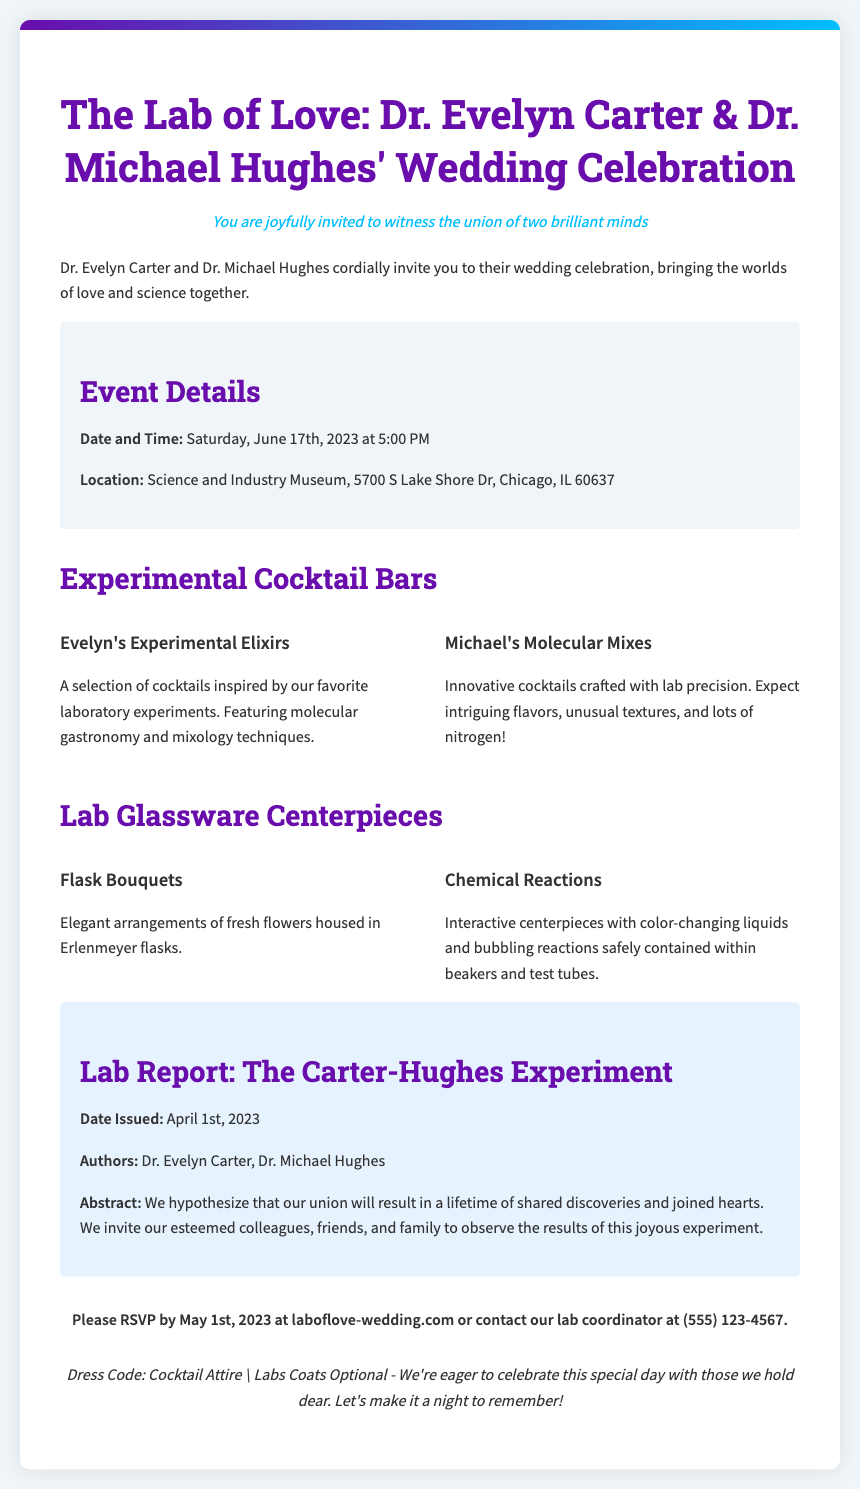What are the names of the couple getting married? The names of the couple, as mentioned in the title, are Dr. Evelyn Carter and Dr. Michael Hughes.
Answer: Dr. Evelyn Carter & Dr. Michael Hughes When is the wedding celebration taking place? The date of the wedding is specified in the event details section of the document.
Answer: June 17th, 2023 Where is the wedding celebration located? The location of the celebration is stated in the event details.
Answer: Science and Industry Museum What is one of the cocktail bars named? The names of the cocktail bars are mentioned in the corresponding section, one of which is Evelyn's Experimental Elixirs.
Answer: Evelyn's Experimental Elixirs What unique feature is included in the centerpieces? The centerpieces include specific elements, one of which is mentioned as color-changing liquids.
Answer: Color-changing liquids What is the RSVP deadline? The RSVP deadline is specified in the RSVP section of the document.
Answer: May 1st, 2023 What attire is suggested for guests? The dress code is indicated in the footer of the invitation.
Answer: Cocktail Attire How are the invitations styled? The style of the invitations is described at the beginning of the document.
Answer: Lab reports 